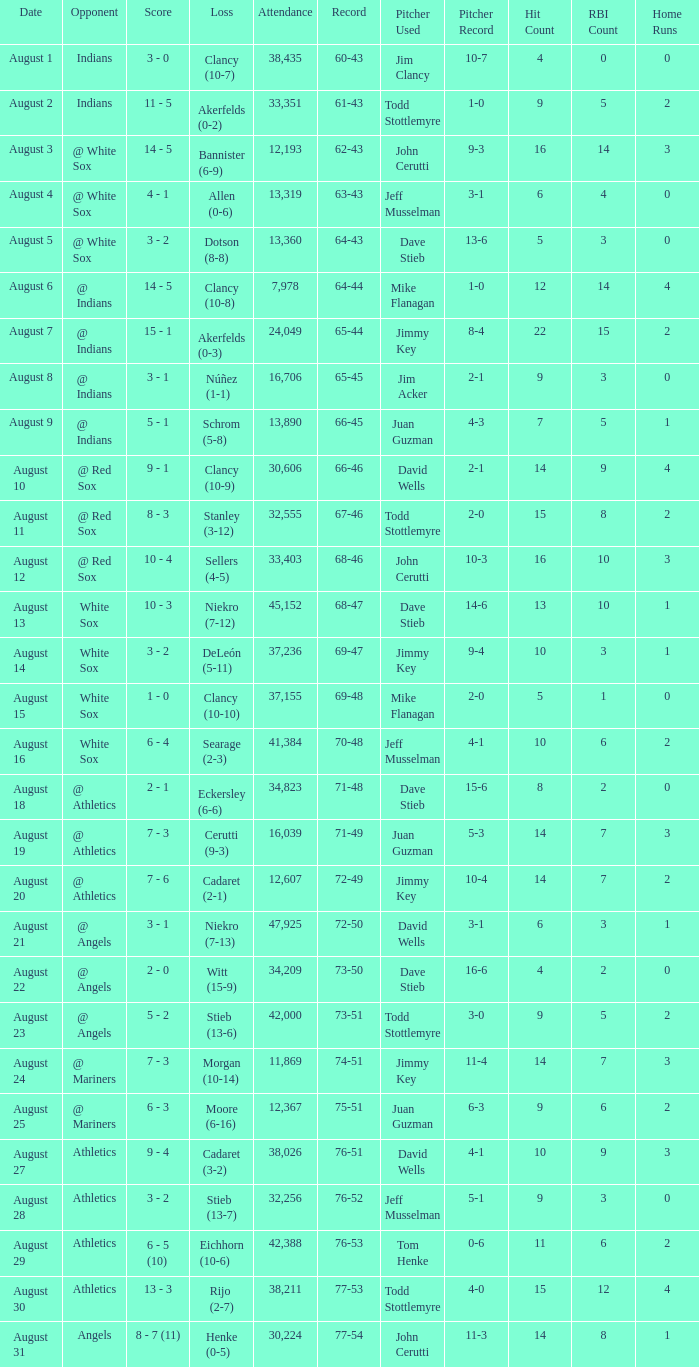What was the attendance when the record was 77-54? 30224.0. 